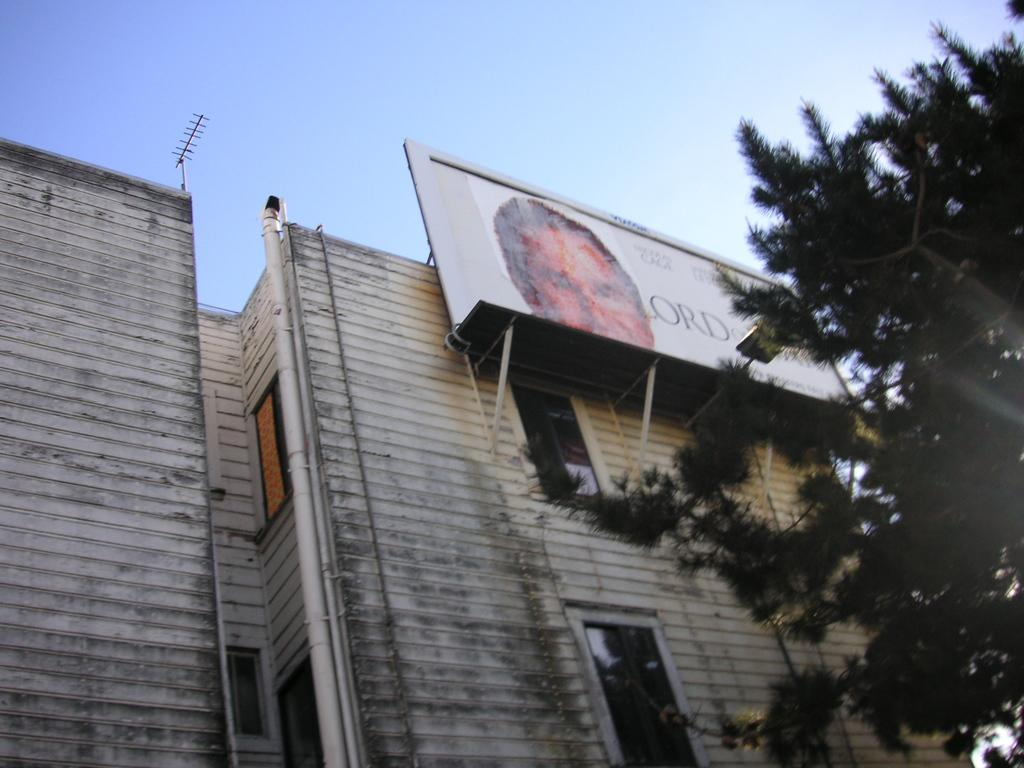What is the main structure in the center of the image? There is a building in the center of the image. What type of vegetation is on the right side of the image? There is a tree on the right side of the image. What is attached to the building in the image? There is a board on the building. What other object can be seen on the building? There is an antenna in the image. What is visible at the top of the image? The sky is visible at the top of the image. What type of riddle is written on the bed in the image? There is no bed present in the image, and therefore no riddle can be found on it. 